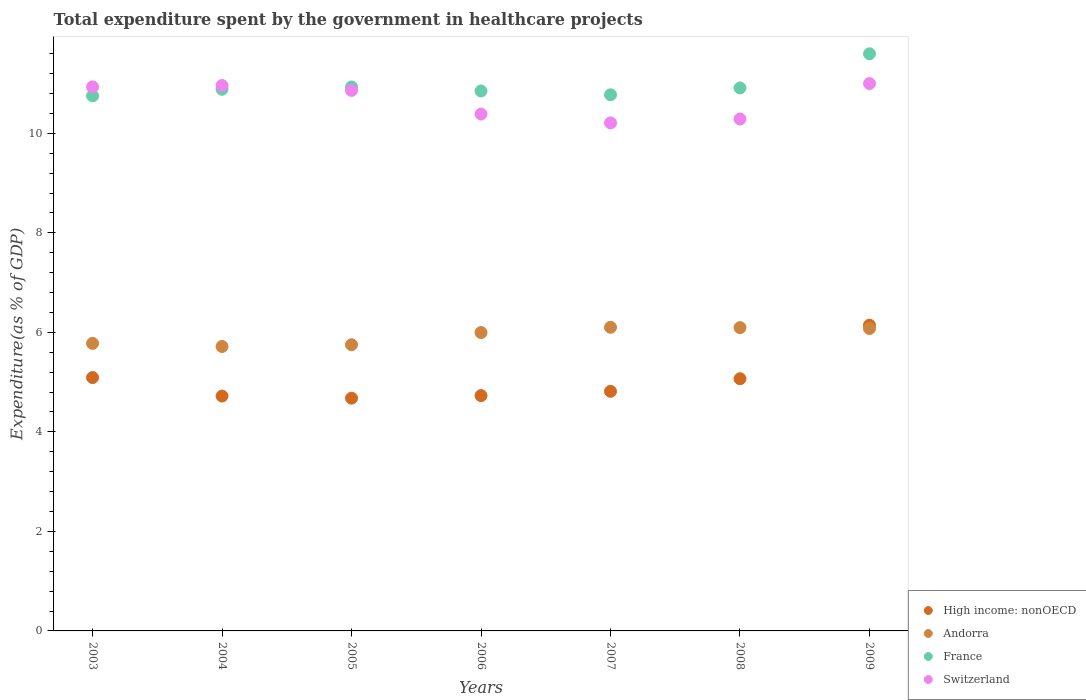What is the total expenditure spent by the government in healthcare projects in High income: nonOECD in 2006?
Your answer should be very brief. 4.73. Across all years, what is the maximum total expenditure spent by the government in healthcare projects in Switzerland?
Make the answer very short. 11. Across all years, what is the minimum total expenditure spent by the government in healthcare projects in Andorra?
Ensure brevity in your answer.  5.72. In which year was the total expenditure spent by the government in healthcare projects in Andorra maximum?
Offer a terse response. 2007. In which year was the total expenditure spent by the government in healthcare projects in France minimum?
Your answer should be compact. 2003. What is the total total expenditure spent by the government in healthcare projects in Switzerland in the graph?
Provide a short and direct response. 74.65. What is the difference between the total expenditure spent by the government in healthcare projects in High income: nonOECD in 2006 and that in 2009?
Your answer should be very brief. -1.42. What is the difference between the total expenditure spent by the government in healthcare projects in Andorra in 2006 and the total expenditure spent by the government in healthcare projects in France in 2007?
Give a very brief answer. -4.78. What is the average total expenditure spent by the government in healthcare projects in France per year?
Give a very brief answer. 10.96. In the year 2008, what is the difference between the total expenditure spent by the government in healthcare projects in High income: nonOECD and total expenditure spent by the government in healthcare projects in Switzerland?
Your response must be concise. -5.22. What is the ratio of the total expenditure spent by the government in healthcare projects in Switzerland in 2007 to that in 2008?
Your response must be concise. 0.99. Is the total expenditure spent by the government in healthcare projects in High income: nonOECD in 2005 less than that in 2006?
Your answer should be very brief. Yes. What is the difference between the highest and the second highest total expenditure spent by the government in healthcare projects in Switzerland?
Your response must be concise. 0.04. What is the difference between the highest and the lowest total expenditure spent by the government in healthcare projects in High income: nonOECD?
Your answer should be very brief. 1.47. Is the sum of the total expenditure spent by the government in healthcare projects in France in 2004 and 2008 greater than the maximum total expenditure spent by the government in healthcare projects in High income: nonOECD across all years?
Offer a very short reply. Yes. Is it the case that in every year, the sum of the total expenditure spent by the government in healthcare projects in High income: nonOECD and total expenditure spent by the government in healthcare projects in Andorra  is greater than the total expenditure spent by the government in healthcare projects in France?
Offer a terse response. No. Does the total expenditure spent by the government in healthcare projects in France monotonically increase over the years?
Your answer should be compact. No. Is the total expenditure spent by the government in healthcare projects in High income: nonOECD strictly less than the total expenditure spent by the government in healthcare projects in Andorra over the years?
Your answer should be very brief. No. How many dotlines are there?
Your response must be concise. 4. How many years are there in the graph?
Offer a terse response. 7. Are the values on the major ticks of Y-axis written in scientific E-notation?
Ensure brevity in your answer.  No. Does the graph contain grids?
Your answer should be compact. No. How many legend labels are there?
Your response must be concise. 4. How are the legend labels stacked?
Give a very brief answer. Vertical. What is the title of the graph?
Give a very brief answer. Total expenditure spent by the government in healthcare projects. What is the label or title of the Y-axis?
Provide a short and direct response. Expenditure(as % of GDP). What is the Expenditure(as % of GDP) of High income: nonOECD in 2003?
Keep it short and to the point. 5.09. What is the Expenditure(as % of GDP) in Andorra in 2003?
Provide a succinct answer. 5.78. What is the Expenditure(as % of GDP) in France in 2003?
Give a very brief answer. 10.75. What is the Expenditure(as % of GDP) of Switzerland in 2003?
Keep it short and to the point. 10.93. What is the Expenditure(as % of GDP) in High income: nonOECD in 2004?
Your response must be concise. 4.72. What is the Expenditure(as % of GDP) of Andorra in 2004?
Your response must be concise. 5.72. What is the Expenditure(as % of GDP) of France in 2004?
Offer a terse response. 10.89. What is the Expenditure(as % of GDP) of Switzerland in 2004?
Ensure brevity in your answer.  10.96. What is the Expenditure(as % of GDP) of High income: nonOECD in 2005?
Offer a very short reply. 4.68. What is the Expenditure(as % of GDP) of Andorra in 2005?
Your answer should be compact. 5.75. What is the Expenditure(as % of GDP) of France in 2005?
Offer a very short reply. 10.93. What is the Expenditure(as % of GDP) in Switzerland in 2005?
Your answer should be very brief. 10.86. What is the Expenditure(as % of GDP) in High income: nonOECD in 2006?
Make the answer very short. 4.73. What is the Expenditure(as % of GDP) of Andorra in 2006?
Provide a short and direct response. 6. What is the Expenditure(as % of GDP) of France in 2006?
Keep it short and to the point. 10.85. What is the Expenditure(as % of GDP) of Switzerland in 2006?
Provide a short and direct response. 10.39. What is the Expenditure(as % of GDP) in High income: nonOECD in 2007?
Provide a succinct answer. 4.82. What is the Expenditure(as % of GDP) of Andorra in 2007?
Give a very brief answer. 6.1. What is the Expenditure(as % of GDP) of France in 2007?
Provide a short and direct response. 10.78. What is the Expenditure(as % of GDP) of Switzerland in 2007?
Make the answer very short. 10.21. What is the Expenditure(as % of GDP) of High income: nonOECD in 2008?
Give a very brief answer. 5.07. What is the Expenditure(as % of GDP) of Andorra in 2008?
Provide a succinct answer. 6.1. What is the Expenditure(as % of GDP) in France in 2008?
Your answer should be very brief. 10.91. What is the Expenditure(as % of GDP) in Switzerland in 2008?
Offer a very short reply. 10.29. What is the Expenditure(as % of GDP) of High income: nonOECD in 2009?
Offer a very short reply. 6.15. What is the Expenditure(as % of GDP) in Andorra in 2009?
Your answer should be compact. 6.08. What is the Expenditure(as % of GDP) of France in 2009?
Offer a terse response. 11.6. What is the Expenditure(as % of GDP) of Switzerland in 2009?
Keep it short and to the point. 11. Across all years, what is the maximum Expenditure(as % of GDP) in High income: nonOECD?
Provide a short and direct response. 6.15. Across all years, what is the maximum Expenditure(as % of GDP) of Andorra?
Offer a terse response. 6.1. Across all years, what is the maximum Expenditure(as % of GDP) of France?
Provide a succinct answer. 11.6. Across all years, what is the maximum Expenditure(as % of GDP) in Switzerland?
Offer a very short reply. 11. Across all years, what is the minimum Expenditure(as % of GDP) in High income: nonOECD?
Your answer should be very brief. 4.68. Across all years, what is the minimum Expenditure(as % of GDP) of Andorra?
Ensure brevity in your answer.  5.72. Across all years, what is the minimum Expenditure(as % of GDP) in France?
Your response must be concise. 10.75. Across all years, what is the minimum Expenditure(as % of GDP) of Switzerland?
Make the answer very short. 10.21. What is the total Expenditure(as % of GDP) in High income: nonOECD in the graph?
Your answer should be compact. 35.25. What is the total Expenditure(as % of GDP) in Andorra in the graph?
Provide a succinct answer. 41.52. What is the total Expenditure(as % of GDP) in France in the graph?
Make the answer very short. 76.71. What is the total Expenditure(as % of GDP) in Switzerland in the graph?
Provide a succinct answer. 74.65. What is the difference between the Expenditure(as % of GDP) of High income: nonOECD in 2003 and that in 2004?
Ensure brevity in your answer.  0.37. What is the difference between the Expenditure(as % of GDP) in Andorra in 2003 and that in 2004?
Your response must be concise. 0.06. What is the difference between the Expenditure(as % of GDP) of France in 2003 and that in 2004?
Make the answer very short. -0.13. What is the difference between the Expenditure(as % of GDP) of Switzerland in 2003 and that in 2004?
Your answer should be very brief. -0.03. What is the difference between the Expenditure(as % of GDP) in High income: nonOECD in 2003 and that in 2005?
Offer a very short reply. 0.41. What is the difference between the Expenditure(as % of GDP) of Andorra in 2003 and that in 2005?
Make the answer very short. 0.03. What is the difference between the Expenditure(as % of GDP) in France in 2003 and that in 2005?
Provide a short and direct response. -0.18. What is the difference between the Expenditure(as % of GDP) in Switzerland in 2003 and that in 2005?
Provide a short and direct response. 0.07. What is the difference between the Expenditure(as % of GDP) in High income: nonOECD in 2003 and that in 2006?
Provide a short and direct response. 0.36. What is the difference between the Expenditure(as % of GDP) of Andorra in 2003 and that in 2006?
Offer a terse response. -0.22. What is the difference between the Expenditure(as % of GDP) in France in 2003 and that in 2006?
Your answer should be very brief. -0.1. What is the difference between the Expenditure(as % of GDP) of Switzerland in 2003 and that in 2006?
Offer a terse response. 0.55. What is the difference between the Expenditure(as % of GDP) of High income: nonOECD in 2003 and that in 2007?
Your response must be concise. 0.28. What is the difference between the Expenditure(as % of GDP) of Andorra in 2003 and that in 2007?
Your answer should be very brief. -0.32. What is the difference between the Expenditure(as % of GDP) of France in 2003 and that in 2007?
Keep it short and to the point. -0.02. What is the difference between the Expenditure(as % of GDP) in Switzerland in 2003 and that in 2007?
Provide a short and direct response. 0.72. What is the difference between the Expenditure(as % of GDP) in High income: nonOECD in 2003 and that in 2008?
Keep it short and to the point. 0.02. What is the difference between the Expenditure(as % of GDP) in Andorra in 2003 and that in 2008?
Offer a terse response. -0.32. What is the difference between the Expenditure(as % of GDP) in France in 2003 and that in 2008?
Provide a succinct answer. -0.16. What is the difference between the Expenditure(as % of GDP) of Switzerland in 2003 and that in 2008?
Offer a very short reply. 0.65. What is the difference between the Expenditure(as % of GDP) in High income: nonOECD in 2003 and that in 2009?
Your answer should be compact. -1.05. What is the difference between the Expenditure(as % of GDP) in Andorra in 2003 and that in 2009?
Ensure brevity in your answer.  -0.3. What is the difference between the Expenditure(as % of GDP) in France in 2003 and that in 2009?
Your answer should be compact. -0.85. What is the difference between the Expenditure(as % of GDP) in Switzerland in 2003 and that in 2009?
Provide a short and direct response. -0.07. What is the difference between the Expenditure(as % of GDP) in High income: nonOECD in 2004 and that in 2005?
Offer a terse response. 0.04. What is the difference between the Expenditure(as % of GDP) in Andorra in 2004 and that in 2005?
Make the answer very short. -0.03. What is the difference between the Expenditure(as % of GDP) in France in 2004 and that in 2005?
Your answer should be very brief. -0.05. What is the difference between the Expenditure(as % of GDP) in Switzerland in 2004 and that in 2005?
Your response must be concise. 0.1. What is the difference between the Expenditure(as % of GDP) of High income: nonOECD in 2004 and that in 2006?
Keep it short and to the point. -0.01. What is the difference between the Expenditure(as % of GDP) of Andorra in 2004 and that in 2006?
Your answer should be compact. -0.28. What is the difference between the Expenditure(as % of GDP) in France in 2004 and that in 2006?
Provide a short and direct response. 0.03. What is the difference between the Expenditure(as % of GDP) of Switzerland in 2004 and that in 2006?
Make the answer very short. 0.57. What is the difference between the Expenditure(as % of GDP) in High income: nonOECD in 2004 and that in 2007?
Give a very brief answer. -0.1. What is the difference between the Expenditure(as % of GDP) in Andorra in 2004 and that in 2007?
Keep it short and to the point. -0.39. What is the difference between the Expenditure(as % of GDP) in France in 2004 and that in 2007?
Give a very brief answer. 0.11. What is the difference between the Expenditure(as % of GDP) in Switzerland in 2004 and that in 2007?
Ensure brevity in your answer.  0.75. What is the difference between the Expenditure(as % of GDP) of High income: nonOECD in 2004 and that in 2008?
Your response must be concise. -0.35. What is the difference between the Expenditure(as % of GDP) in Andorra in 2004 and that in 2008?
Provide a succinct answer. -0.38. What is the difference between the Expenditure(as % of GDP) in France in 2004 and that in 2008?
Ensure brevity in your answer.  -0.03. What is the difference between the Expenditure(as % of GDP) of Switzerland in 2004 and that in 2008?
Keep it short and to the point. 0.67. What is the difference between the Expenditure(as % of GDP) of High income: nonOECD in 2004 and that in 2009?
Your response must be concise. -1.42. What is the difference between the Expenditure(as % of GDP) of Andorra in 2004 and that in 2009?
Provide a succinct answer. -0.36. What is the difference between the Expenditure(as % of GDP) in France in 2004 and that in 2009?
Give a very brief answer. -0.71. What is the difference between the Expenditure(as % of GDP) of Switzerland in 2004 and that in 2009?
Provide a succinct answer. -0.04. What is the difference between the Expenditure(as % of GDP) of High income: nonOECD in 2005 and that in 2006?
Give a very brief answer. -0.05. What is the difference between the Expenditure(as % of GDP) of Andorra in 2005 and that in 2006?
Offer a very short reply. -0.25. What is the difference between the Expenditure(as % of GDP) in France in 2005 and that in 2006?
Offer a very short reply. 0.08. What is the difference between the Expenditure(as % of GDP) in Switzerland in 2005 and that in 2006?
Provide a short and direct response. 0.48. What is the difference between the Expenditure(as % of GDP) of High income: nonOECD in 2005 and that in 2007?
Your answer should be very brief. -0.14. What is the difference between the Expenditure(as % of GDP) in Andorra in 2005 and that in 2007?
Ensure brevity in your answer.  -0.35. What is the difference between the Expenditure(as % of GDP) of France in 2005 and that in 2007?
Offer a very short reply. 0.16. What is the difference between the Expenditure(as % of GDP) in Switzerland in 2005 and that in 2007?
Make the answer very short. 0.65. What is the difference between the Expenditure(as % of GDP) in High income: nonOECD in 2005 and that in 2008?
Offer a terse response. -0.39. What is the difference between the Expenditure(as % of GDP) of Andorra in 2005 and that in 2008?
Make the answer very short. -0.34. What is the difference between the Expenditure(as % of GDP) of France in 2005 and that in 2008?
Ensure brevity in your answer.  0.02. What is the difference between the Expenditure(as % of GDP) of Switzerland in 2005 and that in 2008?
Provide a succinct answer. 0.57. What is the difference between the Expenditure(as % of GDP) of High income: nonOECD in 2005 and that in 2009?
Ensure brevity in your answer.  -1.47. What is the difference between the Expenditure(as % of GDP) of Andorra in 2005 and that in 2009?
Your answer should be very brief. -0.33. What is the difference between the Expenditure(as % of GDP) of France in 2005 and that in 2009?
Keep it short and to the point. -0.67. What is the difference between the Expenditure(as % of GDP) of Switzerland in 2005 and that in 2009?
Provide a short and direct response. -0.14. What is the difference between the Expenditure(as % of GDP) in High income: nonOECD in 2006 and that in 2007?
Your answer should be very brief. -0.09. What is the difference between the Expenditure(as % of GDP) in Andorra in 2006 and that in 2007?
Give a very brief answer. -0.11. What is the difference between the Expenditure(as % of GDP) of France in 2006 and that in 2007?
Give a very brief answer. 0.08. What is the difference between the Expenditure(as % of GDP) of Switzerland in 2006 and that in 2007?
Your answer should be very brief. 0.18. What is the difference between the Expenditure(as % of GDP) in High income: nonOECD in 2006 and that in 2008?
Ensure brevity in your answer.  -0.34. What is the difference between the Expenditure(as % of GDP) in Andorra in 2006 and that in 2008?
Provide a short and direct response. -0.1. What is the difference between the Expenditure(as % of GDP) in France in 2006 and that in 2008?
Provide a short and direct response. -0.06. What is the difference between the Expenditure(as % of GDP) of Switzerland in 2006 and that in 2008?
Your answer should be very brief. 0.1. What is the difference between the Expenditure(as % of GDP) in High income: nonOECD in 2006 and that in 2009?
Give a very brief answer. -1.42. What is the difference between the Expenditure(as % of GDP) in Andorra in 2006 and that in 2009?
Give a very brief answer. -0.08. What is the difference between the Expenditure(as % of GDP) of France in 2006 and that in 2009?
Your response must be concise. -0.75. What is the difference between the Expenditure(as % of GDP) of Switzerland in 2006 and that in 2009?
Your answer should be compact. -0.61. What is the difference between the Expenditure(as % of GDP) in High income: nonOECD in 2007 and that in 2008?
Ensure brevity in your answer.  -0.25. What is the difference between the Expenditure(as % of GDP) in Andorra in 2007 and that in 2008?
Your response must be concise. 0.01. What is the difference between the Expenditure(as % of GDP) in France in 2007 and that in 2008?
Give a very brief answer. -0.14. What is the difference between the Expenditure(as % of GDP) in Switzerland in 2007 and that in 2008?
Your answer should be compact. -0.08. What is the difference between the Expenditure(as % of GDP) of High income: nonOECD in 2007 and that in 2009?
Ensure brevity in your answer.  -1.33. What is the difference between the Expenditure(as % of GDP) in Andorra in 2007 and that in 2009?
Offer a terse response. 0.03. What is the difference between the Expenditure(as % of GDP) of France in 2007 and that in 2009?
Make the answer very short. -0.82. What is the difference between the Expenditure(as % of GDP) in Switzerland in 2007 and that in 2009?
Ensure brevity in your answer.  -0.79. What is the difference between the Expenditure(as % of GDP) in High income: nonOECD in 2008 and that in 2009?
Offer a very short reply. -1.08. What is the difference between the Expenditure(as % of GDP) in Andorra in 2008 and that in 2009?
Your answer should be very brief. 0.02. What is the difference between the Expenditure(as % of GDP) in France in 2008 and that in 2009?
Offer a terse response. -0.69. What is the difference between the Expenditure(as % of GDP) of Switzerland in 2008 and that in 2009?
Provide a short and direct response. -0.71. What is the difference between the Expenditure(as % of GDP) in High income: nonOECD in 2003 and the Expenditure(as % of GDP) in Andorra in 2004?
Keep it short and to the point. -0.62. What is the difference between the Expenditure(as % of GDP) of High income: nonOECD in 2003 and the Expenditure(as % of GDP) of France in 2004?
Give a very brief answer. -5.79. What is the difference between the Expenditure(as % of GDP) in High income: nonOECD in 2003 and the Expenditure(as % of GDP) in Switzerland in 2004?
Your response must be concise. -5.87. What is the difference between the Expenditure(as % of GDP) in Andorra in 2003 and the Expenditure(as % of GDP) in France in 2004?
Make the answer very short. -5.11. What is the difference between the Expenditure(as % of GDP) of Andorra in 2003 and the Expenditure(as % of GDP) of Switzerland in 2004?
Provide a short and direct response. -5.18. What is the difference between the Expenditure(as % of GDP) of France in 2003 and the Expenditure(as % of GDP) of Switzerland in 2004?
Keep it short and to the point. -0.21. What is the difference between the Expenditure(as % of GDP) of High income: nonOECD in 2003 and the Expenditure(as % of GDP) of Andorra in 2005?
Your answer should be compact. -0.66. What is the difference between the Expenditure(as % of GDP) of High income: nonOECD in 2003 and the Expenditure(as % of GDP) of France in 2005?
Your response must be concise. -5.84. What is the difference between the Expenditure(as % of GDP) in High income: nonOECD in 2003 and the Expenditure(as % of GDP) in Switzerland in 2005?
Provide a succinct answer. -5.77. What is the difference between the Expenditure(as % of GDP) in Andorra in 2003 and the Expenditure(as % of GDP) in France in 2005?
Your response must be concise. -5.15. What is the difference between the Expenditure(as % of GDP) of Andorra in 2003 and the Expenditure(as % of GDP) of Switzerland in 2005?
Ensure brevity in your answer.  -5.08. What is the difference between the Expenditure(as % of GDP) in France in 2003 and the Expenditure(as % of GDP) in Switzerland in 2005?
Your response must be concise. -0.11. What is the difference between the Expenditure(as % of GDP) of High income: nonOECD in 2003 and the Expenditure(as % of GDP) of Andorra in 2006?
Offer a terse response. -0.91. What is the difference between the Expenditure(as % of GDP) of High income: nonOECD in 2003 and the Expenditure(as % of GDP) of France in 2006?
Keep it short and to the point. -5.76. What is the difference between the Expenditure(as % of GDP) in High income: nonOECD in 2003 and the Expenditure(as % of GDP) in Switzerland in 2006?
Ensure brevity in your answer.  -5.3. What is the difference between the Expenditure(as % of GDP) of Andorra in 2003 and the Expenditure(as % of GDP) of France in 2006?
Ensure brevity in your answer.  -5.07. What is the difference between the Expenditure(as % of GDP) in Andorra in 2003 and the Expenditure(as % of GDP) in Switzerland in 2006?
Offer a very short reply. -4.61. What is the difference between the Expenditure(as % of GDP) in France in 2003 and the Expenditure(as % of GDP) in Switzerland in 2006?
Your response must be concise. 0.37. What is the difference between the Expenditure(as % of GDP) in High income: nonOECD in 2003 and the Expenditure(as % of GDP) in Andorra in 2007?
Offer a very short reply. -1.01. What is the difference between the Expenditure(as % of GDP) in High income: nonOECD in 2003 and the Expenditure(as % of GDP) in France in 2007?
Your answer should be compact. -5.68. What is the difference between the Expenditure(as % of GDP) of High income: nonOECD in 2003 and the Expenditure(as % of GDP) of Switzerland in 2007?
Provide a succinct answer. -5.12. What is the difference between the Expenditure(as % of GDP) in Andorra in 2003 and the Expenditure(as % of GDP) in France in 2007?
Make the answer very short. -5. What is the difference between the Expenditure(as % of GDP) of Andorra in 2003 and the Expenditure(as % of GDP) of Switzerland in 2007?
Keep it short and to the point. -4.43. What is the difference between the Expenditure(as % of GDP) in France in 2003 and the Expenditure(as % of GDP) in Switzerland in 2007?
Your response must be concise. 0.54. What is the difference between the Expenditure(as % of GDP) in High income: nonOECD in 2003 and the Expenditure(as % of GDP) in Andorra in 2008?
Provide a succinct answer. -1. What is the difference between the Expenditure(as % of GDP) of High income: nonOECD in 2003 and the Expenditure(as % of GDP) of France in 2008?
Make the answer very short. -5.82. What is the difference between the Expenditure(as % of GDP) in High income: nonOECD in 2003 and the Expenditure(as % of GDP) in Switzerland in 2008?
Your answer should be compact. -5.2. What is the difference between the Expenditure(as % of GDP) in Andorra in 2003 and the Expenditure(as % of GDP) in France in 2008?
Your response must be concise. -5.13. What is the difference between the Expenditure(as % of GDP) in Andorra in 2003 and the Expenditure(as % of GDP) in Switzerland in 2008?
Your answer should be very brief. -4.51. What is the difference between the Expenditure(as % of GDP) in France in 2003 and the Expenditure(as % of GDP) in Switzerland in 2008?
Your response must be concise. 0.46. What is the difference between the Expenditure(as % of GDP) of High income: nonOECD in 2003 and the Expenditure(as % of GDP) of Andorra in 2009?
Your response must be concise. -0.99. What is the difference between the Expenditure(as % of GDP) of High income: nonOECD in 2003 and the Expenditure(as % of GDP) of France in 2009?
Keep it short and to the point. -6.51. What is the difference between the Expenditure(as % of GDP) of High income: nonOECD in 2003 and the Expenditure(as % of GDP) of Switzerland in 2009?
Ensure brevity in your answer.  -5.91. What is the difference between the Expenditure(as % of GDP) in Andorra in 2003 and the Expenditure(as % of GDP) in France in 2009?
Your answer should be very brief. -5.82. What is the difference between the Expenditure(as % of GDP) of Andorra in 2003 and the Expenditure(as % of GDP) of Switzerland in 2009?
Give a very brief answer. -5.22. What is the difference between the Expenditure(as % of GDP) of France in 2003 and the Expenditure(as % of GDP) of Switzerland in 2009?
Your response must be concise. -0.25. What is the difference between the Expenditure(as % of GDP) in High income: nonOECD in 2004 and the Expenditure(as % of GDP) in Andorra in 2005?
Keep it short and to the point. -1.03. What is the difference between the Expenditure(as % of GDP) in High income: nonOECD in 2004 and the Expenditure(as % of GDP) in France in 2005?
Your answer should be compact. -6.21. What is the difference between the Expenditure(as % of GDP) in High income: nonOECD in 2004 and the Expenditure(as % of GDP) in Switzerland in 2005?
Your answer should be very brief. -6.14. What is the difference between the Expenditure(as % of GDP) in Andorra in 2004 and the Expenditure(as % of GDP) in France in 2005?
Your response must be concise. -5.22. What is the difference between the Expenditure(as % of GDP) in Andorra in 2004 and the Expenditure(as % of GDP) in Switzerland in 2005?
Offer a very short reply. -5.15. What is the difference between the Expenditure(as % of GDP) in France in 2004 and the Expenditure(as % of GDP) in Switzerland in 2005?
Ensure brevity in your answer.  0.02. What is the difference between the Expenditure(as % of GDP) in High income: nonOECD in 2004 and the Expenditure(as % of GDP) in Andorra in 2006?
Provide a succinct answer. -1.28. What is the difference between the Expenditure(as % of GDP) of High income: nonOECD in 2004 and the Expenditure(as % of GDP) of France in 2006?
Offer a terse response. -6.13. What is the difference between the Expenditure(as % of GDP) in High income: nonOECD in 2004 and the Expenditure(as % of GDP) in Switzerland in 2006?
Provide a succinct answer. -5.67. What is the difference between the Expenditure(as % of GDP) in Andorra in 2004 and the Expenditure(as % of GDP) in France in 2006?
Ensure brevity in your answer.  -5.14. What is the difference between the Expenditure(as % of GDP) in Andorra in 2004 and the Expenditure(as % of GDP) in Switzerland in 2006?
Offer a terse response. -4.67. What is the difference between the Expenditure(as % of GDP) in France in 2004 and the Expenditure(as % of GDP) in Switzerland in 2006?
Your answer should be compact. 0.5. What is the difference between the Expenditure(as % of GDP) in High income: nonOECD in 2004 and the Expenditure(as % of GDP) in Andorra in 2007?
Make the answer very short. -1.38. What is the difference between the Expenditure(as % of GDP) of High income: nonOECD in 2004 and the Expenditure(as % of GDP) of France in 2007?
Provide a short and direct response. -6.05. What is the difference between the Expenditure(as % of GDP) in High income: nonOECD in 2004 and the Expenditure(as % of GDP) in Switzerland in 2007?
Give a very brief answer. -5.49. What is the difference between the Expenditure(as % of GDP) in Andorra in 2004 and the Expenditure(as % of GDP) in France in 2007?
Give a very brief answer. -5.06. What is the difference between the Expenditure(as % of GDP) in Andorra in 2004 and the Expenditure(as % of GDP) in Switzerland in 2007?
Offer a very short reply. -4.49. What is the difference between the Expenditure(as % of GDP) in France in 2004 and the Expenditure(as % of GDP) in Switzerland in 2007?
Provide a short and direct response. 0.68. What is the difference between the Expenditure(as % of GDP) of High income: nonOECD in 2004 and the Expenditure(as % of GDP) of Andorra in 2008?
Provide a succinct answer. -1.38. What is the difference between the Expenditure(as % of GDP) of High income: nonOECD in 2004 and the Expenditure(as % of GDP) of France in 2008?
Offer a terse response. -6.19. What is the difference between the Expenditure(as % of GDP) in High income: nonOECD in 2004 and the Expenditure(as % of GDP) in Switzerland in 2008?
Offer a terse response. -5.57. What is the difference between the Expenditure(as % of GDP) of Andorra in 2004 and the Expenditure(as % of GDP) of France in 2008?
Your answer should be compact. -5.2. What is the difference between the Expenditure(as % of GDP) in Andorra in 2004 and the Expenditure(as % of GDP) in Switzerland in 2008?
Your answer should be compact. -4.57. What is the difference between the Expenditure(as % of GDP) of France in 2004 and the Expenditure(as % of GDP) of Switzerland in 2008?
Keep it short and to the point. 0.6. What is the difference between the Expenditure(as % of GDP) of High income: nonOECD in 2004 and the Expenditure(as % of GDP) of Andorra in 2009?
Make the answer very short. -1.36. What is the difference between the Expenditure(as % of GDP) in High income: nonOECD in 2004 and the Expenditure(as % of GDP) in France in 2009?
Give a very brief answer. -6.88. What is the difference between the Expenditure(as % of GDP) in High income: nonOECD in 2004 and the Expenditure(as % of GDP) in Switzerland in 2009?
Your response must be concise. -6.28. What is the difference between the Expenditure(as % of GDP) in Andorra in 2004 and the Expenditure(as % of GDP) in France in 2009?
Provide a succinct answer. -5.88. What is the difference between the Expenditure(as % of GDP) of Andorra in 2004 and the Expenditure(as % of GDP) of Switzerland in 2009?
Offer a very short reply. -5.28. What is the difference between the Expenditure(as % of GDP) in France in 2004 and the Expenditure(as % of GDP) in Switzerland in 2009?
Give a very brief answer. -0.11. What is the difference between the Expenditure(as % of GDP) of High income: nonOECD in 2005 and the Expenditure(as % of GDP) of Andorra in 2006?
Offer a very short reply. -1.32. What is the difference between the Expenditure(as % of GDP) in High income: nonOECD in 2005 and the Expenditure(as % of GDP) in France in 2006?
Your answer should be very brief. -6.17. What is the difference between the Expenditure(as % of GDP) in High income: nonOECD in 2005 and the Expenditure(as % of GDP) in Switzerland in 2006?
Give a very brief answer. -5.71. What is the difference between the Expenditure(as % of GDP) in Andorra in 2005 and the Expenditure(as % of GDP) in France in 2006?
Your answer should be very brief. -5.1. What is the difference between the Expenditure(as % of GDP) of Andorra in 2005 and the Expenditure(as % of GDP) of Switzerland in 2006?
Offer a terse response. -4.64. What is the difference between the Expenditure(as % of GDP) of France in 2005 and the Expenditure(as % of GDP) of Switzerland in 2006?
Your answer should be very brief. 0.54. What is the difference between the Expenditure(as % of GDP) of High income: nonOECD in 2005 and the Expenditure(as % of GDP) of Andorra in 2007?
Provide a short and direct response. -1.43. What is the difference between the Expenditure(as % of GDP) of High income: nonOECD in 2005 and the Expenditure(as % of GDP) of France in 2007?
Provide a succinct answer. -6.1. What is the difference between the Expenditure(as % of GDP) in High income: nonOECD in 2005 and the Expenditure(as % of GDP) in Switzerland in 2007?
Your response must be concise. -5.53. What is the difference between the Expenditure(as % of GDP) of Andorra in 2005 and the Expenditure(as % of GDP) of France in 2007?
Your response must be concise. -5.02. What is the difference between the Expenditure(as % of GDP) in Andorra in 2005 and the Expenditure(as % of GDP) in Switzerland in 2007?
Ensure brevity in your answer.  -4.46. What is the difference between the Expenditure(as % of GDP) in France in 2005 and the Expenditure(as % of GDP) in Switzerland in 2007?
Your response must be concise. 0.72. What is the difference between the Expenditure(as % of GDP) of High income: nonOECD in 2005 and the Expenditure(as % of GDP) of Andorra in 2008?
Provide a short and direct response. -1.42. What is the difference between the Expenditure(as % of GDP) of High income: nonOECD in 2005 and the Expenditure(as % of GDP) of France in 2008?
Your answer should be compact. -6.24. What is the difference between the Expenditure(as % of GDP) of High income: nonOECD in 2005 and the Expenditure(as % of GDP) of Switzerland in 2008?
Your answer should be very brief. -5.61. What is the difference between the Expenditure(as % of GDP) of Andorra in 2005 and the Expenditure(as % of GDP) of France in 2008?
Make the answer very short. -5.16. What is the difference between the Expenditure(as % of GDP) in Andorra in 2005 and the Expenditure(as % of GDP) in Switzerland in 2008?
Your answer should be very brief. -4.54. What is the difference between the Expenditure(as % of GDP) of France in 2005 and the Expenditure(as % of GDP) of Switzerland in 2008?
Your response must be concise. 0.64. What is the difference between the Expenditure(as % of GDP) of High income: nonOECD in 2005 and the Expenditure(as % of GDP) of Andorra in 2009?
Offer a terse response. -1.4. What is the difference between the Expenditure(as % of GDP) in High income: nonOECD in 2005 and the Expenditure(as % of GDP) in France in 2009?
Ensure brevity in your answer.  -6.92. What is the difference between the Expenditure(as % of GDP) of High income: nonOECD in 2005 and the Expenditure(as % of GDP) of Switzerland in 2009?
Give a very brief answer. -6.32. What is the difference between the Expenditure(as % of GDP) of Andorra in 2005 and the Expenditure(as % of GDP) of France in 2009?
Your answer should be very brief. -5.85. What is the difference between the Expenditure(as % of GDP) in Andorra in 2005 and the Expenditure(as % of GDP) in Switzerland in 2009?
Offer a terse response. -5.25. What is the difference between the Expenditure(as % of GDP) of France in 2005 and the Expenditure(as % of GDP) of Switzerland in 2009?
Offer a very short reply. -0.07. What is the difference between the Expenditure(as % of GDP) in High income: nonOECD in 2006 and the Expenditure(as % of GDP) in Andorra in 2007?
Provide a succinct answer. -1.37. What is the difference between the Expenditure(as % of GDP) in High income: nonOECD in 2006 and the Expenditure(as % of GDP) in France in 2007?
Keep it short and to the point. -6.05. What is the difference between the Expenditure(as % of GDP) of High income: nonOECD in 2006 and the Expenditure(as % of GDP) of Switzerland in 2007?
Provide a short and direct response. -5.48. What is the difference between the Expenditure(as % of GDP) of Andorra in 2006 and the Expenditure(as % of GDP) of France in 2007?
Offer a terse response. -4.78. What is the difference between the Expenditure(as % of GDP) of Andorra in 2006 and the Expenditure(as % of GDP) of Switzerland in 2007?
Provide a succinct answer. -4.21. What is the difference between the Expenditure(as % of GDP) of France in 2006 and the Expenditure(as % of GDP) of Switzerland in 2007?
Keep it short and to the point. 0.64. What is the difference between the Expenditure(as % of GDP) of High income: nonOECD in 2006 and the Expenditure(as % of GDP) of Andorra in 2008?
Ensure brevity in your answer.  -1.37. What is the difference between the Expenditure(as % of GDP) of High income: nonOECD in 2006 and the Expenditure(as % of GDP) of France in 2008?
Your answer should be very brief. -6.18. What is the difference between the Expenditure(as % of GDP) of High income: nonOECD in 2006 and the Expenditure(as % of GDP) of Switzerland in 2008?
Your response must be concise. -5.56. What is the difference between the Expenditure(as % of GDP) in Andorra in 2006 and the Expenditure(as % of GDP) in France in 2008?
Ensure brevity in your answer.  -4.92. What is the difference between the Expenditure(as % of GDP) in Andorra in 2006 and the Expenditure(as % of GDP) in Switzerland in 2008?
Provide a short and direct response. -4.29. What is the difference between the Expenditure(as % of GDP) of France in 2006 and the Expenditure(as % of GDP) of Switzerland in 2008?
Offer a very short reply. 0.56. What is the difference between the Expenditure(as % of GDP) of High income: nonOECD in 2006 and the Expenditure(as % of GDP) of Andorra in 2009?
Your response must be concise. -1.35. What is the difference between the Expenditure(as % of GDP) of High income: nonOECD in 2006 and the Expenditure(as % of GDP) of France in 2009?
Offer a terse response. -6.87. What is the difference between the Expenditure(as % of GDP) of High income: nonOECD in 2006 and the Expenditure(as % of GDP) of Switzerland in 2009?
Ensure brevity in your answer.  -6.27. What is the difference between the Expenditure(as % of GDP) in Andorra in 2006 and the Expenditure(as % of GDP) in France in 2009?
Provide a succinct answer. -5.6. What is the difference between the Expenditure(as % of GDP) of Andorra in 2006 and the Expenditure(as % of GDP) of Switzerland in 2009?
Give a very brief answer. -5. What is the difference between the Expenditure(as % of GDP) of France in 2006 and the Expenditure(as % of GDP) of Switzerland in 2009?
Offer a terse response. -0.15. What is the difference between the Expenditure(as % of GDP) of High income: nonOECD in 2007 and the Expenditure(as % of GDP) of Andorra in 2008?
Your answer should be very brief. -1.28. What is the difference between the Expenditure(as % of GDP) in High income: nonOECD in 2007 and the Expenditure(as % of GDP) in France in 2008?
Offer a very short reply. -6.1. What is the difference between the Expenditure(as % of GDP) in High income: nonOECD in 2007 and the Expenditure(as % of GDP) in Switzerland in 2008?
Offer a terse response. -5.47. What is the difference between the Expenditure(as % of GDP) in Andorra in 2007 and the Expenditure(as % of GDP) in France in 2008?
Ensure brevity in your answer.  -4.81. What is the difference between the Expenditure(as % of GDP) of Andorra in 2007 and the Expenditure(as % of GDP) of Switzerland in 2008?
Give a very brief answer. -4.19. What is the difference between the Expenditure(as % of GDP) in France in 2007 and the Expenditure(as % of GDP) in Switzerland in 2008?
Offer a terse response. 0.49. What is the difference between the Expenditure(as % of GDP) in High income: nonOECD in 2007 and the Expenditure(as % of GDP) in Andorra in 2009?
Offer a very short reply. -1.26. What is the difference between the Expenditure(as % of GDP) of High income: nonOECD in 2007 and the Expenditure(as % of GDP) of France in 2009?
Your answer should be very brief. -6.78. What is the difference between the Expenditure(as % of GDP) in High income: nonOECD in 2007 and the Expenditure(as % of GDP) in Switzerland in 2009?
Give a very brief answer. -6.18. What is the difference between the Expenditure(as % of GDP) in Andorra in 2007 and the Expenditure(as % of GDP) in France in 2009?
Your answer should be very brief. -5.5. What is the difference between the Expenditure(as % of GDP) in Andorra in 2007 and the Expenditure(as % of GDP) in Switzerland in 2009?
Your answer should be compact. -4.9. What is the difference between the Expenditure(as % of GDP) of France in 2007 and the Expenditure(as % of GDP) of Switzerland in 2009?
Provide a short and direct response. -0.23. What is the difference between the Expenditure(as % of GDP) in High income: nonOECD in 2008 and the Expenditure(as % of GDP) in Andorra in 2009?
Make the answer very short. -1.01. What is the difference between the Expenditure(as % of GDP) in High income: nonOECD in 2008 and the Expenditure(as % of GDP) in France in 2009?
Give a very brief answer. -6.53. What is the difference between the Expenditure(as % of GDP) of High income: nonOECD in 2008 and the Expenditure(as % of GDP) of Switzerland in 2009?
Provide a succinct answer. -5.93. What is the difference between the Expenditure(as % of GDP) in Andorra in 2008 and the Expenditure(as % of GDP) in France in 2009?
Provide a short and direct response. -5.5. What is the difference between the Expenditure(as % of GDP) of Andorra in 2008 and the Expenditure(as % of GDP) of Switzerland in 2009?
Make the answer very short. -4.9. What is the difference between the Expenditure(as % of GDP) in France in 2008 and the Expenditure(as % of GDP) in Switzerland in 2009?
Offer a very short reply. -0.09. What is the average Expenditure(as % of GDP) in High income: nonOECD per year?
Ensure brevity in your answer.  5.04. What is the average Expenditure(as % of GDP) in Andorra per year?
Offer a very short reply. 5.93. What is the average Expenditure(as % of GDP) of France per year?
Offer a terse response. 10.96. What is the average Expenditure(as % of GDP) of Switzerland per year?
Your response must be concise. 10.66. In the year 2003, what is the difference between the Expenditure(as % of GDP) in High income: nonOECD and Expenditure(as % of GDP) in Andorra?
Give a very brief answer. -0.69. In the year 2003, what is the difference between the Expenditure(as % of GDP) in High income: nonOECD and Expenditure(as % of GDP) in France?
Your answer should be very brief. -5.66. In the year 2003, what is the difference between the Expenditure(as % of GDP) of High income: nonOECD and Expenditure(as % of GDP) of Switzerland?
Provide a succinct answer. -5.84. In the year 2003, what is the difference between the Expenditure(as % of GDP) of Andorra and Expenditure(as % of GDP) of France?
Your response must be concise. -4.97. In the year 2003, what is the difference between the Expenditure(as % of GDP) of Andorra and Expenditure(as % of GDP) of Switzerland?
Your answer should be compact. -5.15. In the year 2003, what is the difference between the Expenditure(as % of GDP) of France and Expenditure(as % of GDP) of Switzerland?
Ensure brevity in your answer.  -0.18. In the year 2004, what is the difference between the Expenditure(as % of GDP) in High income: nonOECD and Expenditure(as % of GDP) in Andorra?
Your response must be concise. -1. In the year 2004, what is the difference between the Expenditure(as % of GDP) of High income: nonOECD and Expenditure(as % of GDP) of France?
Provide a succinct answer. -6.17. In the year 2004, what is the difference between the Expenditure(as % of GDP) of High income: nonOECD and Expenditure(as % of GDP) of Switzerland?
Ensure brevity in your answer.  -6.24. In the year 2004, what is the difference between the Expenditure(as % of GDP) of Andorra and Expenditure(as % of GDP) of France?
Provide a short and direct response. -5.17. In the year 2004, what is the difference between the Expenditure(as % of GDP) in Andorra and Expenditure(as % of GDP) in Switzerland?
Your answer should be compact. -5.24. In the year 2004, what is the difference between the Expenditure(as % of GDP) in France and Expenditure(as % of GDP) in Switzerland?
Offer a terse response. -0.08. In the year 2005, what is the difference between the Expenditure(as % of GDP) of High income: nonOECD and Expenditure(as % of GDP) of Andorra?
Provide a short and direct response. -1.07. In the year 2005, what is the difference between the Expenditure(as % of GDP) in High income: nonOECD and Expenditure(as % of GDP) in France?
Make the answer very short. -6.26. In the year 2005, what is the difference between the Expenditure(as % of GDP) in High income: nonOECD and Expenditure(as % of GDP) in Switzerland?
Give a very brief answer. -6.19. In the year 2005, what is the difference between the Expenditure(as % of GDP) of Andorra and Expenditure(as % of GDP) of France?
Offer a very short reply. -5.18. In the year 2005, what is the difference between the Expenditure(as % of GDP) in Andorra and Expenditure(as % of GDP) in Switzerland?
Keep it short and to the point. -5.11. In the year 2005, what is the difference between the Expenditure(as % of GDP) of France and Expenditure(as % of GDP) of Switzerland?
Provide a short and direct response. 0.07. In the year 2006, what is the difference between the Expenditure(as % of GDP) in High income: nonOECD and Expenditure(as % of GDP) in Andorra?
Ensure brevity in your answer.  -1.27. In the year 2006, what is the difference between the Expenditure(as % of GDP) of High income: nonOECD and Expenditure(as % of GDP) of France?
Offer a terse response. -6.12. In the year 2006, what is the difference between the Expenditure(as % of GDP) of High income: nonOECD and Expenditure(as % of GDP) of Switzerland?
Your response must be concise. -5.66. In the year 2006, what is the difference between the Expenditure(as % of GDP) of Andorra and Expenditure(as % of GDP) of France?
Offer a very short reply. -4.86. In the year 2006, what is the difference between the Expenditure(as % of GDP) in Andorra and Expenditure(as % of GDP) in Switzerland?
Provide a succinct answer. -4.39. In the year 2006, what is the difference between the Expenditure(as % of GDP) in France and Expenditure(as % of GDP) in Switzerland?
Provide a succinct answer. 0.46. In the year 2007, what is the difference between the Expenditure(as % of GDP) of High income: nonOECD and Expenditure(as % of GDP) of Andorra?
Make the answer very short. -1.29. In the year 2007, what is the difference between the Expenditure(as % of GDP) in High income: nonOECD and Expenditure(as % of GDP) in France?
Your answer should be very brief. -5.96. In the year 2007, what is the difference between the Expenditure(as % of GDP) of High income: nonOECD and Expenditure(as % of GDP) of Switzerland?
Your answer should be compact. -5.39. In the year 2007, what is the difference between the Expenditure(as % of GDP) in Andorra and Expenditure(as % of GDP) in France?
Keep it short and to the point. -4.67. In the year 2007, what is the difference between the Expenditure(as % of GDP) in Andorra and Expenditure(as % of GDP) in Switzerland?
Give a very brief answer. -4.11. In the year 2007, what is the difference between the Expenditure(as % of GDP) in France and Expenditure(as % of GDP) in Switzerland?
Your answer should be compact. 0.57. In the year 2008, what is the difference between the Expenditure(as % of GDP) of High income: nonOECD and Expenditure(as % of GDP) of Andorra?
Offer a very short reply. -1.03. In the year 2008, what is the difference between the Expenditure(as % of GDP) in High income: nonOECD and Expenditure(as % of GDP) in France?
Offer a very short reply. -5.84. In the year 2008, what is the difference between the Expenditure(as % of GDP) of High income: nonOECD and Expenditure(as % of GDP) of Switzerland?
Your response must be concise. -5.22. In the year 2008, what is the difference between the Expenditure(as % of GDP) of Andorra and Expenditure(as % of GDP) of France?
Ensure brevity in your answer.  -4.82. In the year 2008, what is the difference between the Expenditure(as % of GDP) of Andorra and Expenditure(as % of GDP) of Switzerland?
Your answer should be very brief. -4.19. In the year 2008, what is the difference between the Expenditure(as % of GDP) of France and Expenditure(as % of GDP) of Switzerland?
Keep it short and to the point. 0.62. In the year 2009, what is the difference between the Expenditure(as % of GDP) in High income: nonOECD and Expenditure(as % of GDP) in Andorra?
Provide a short and direct response. 0.07. In the year 2009, what is the difference between the Expenditure(as % of GDP) of High income: nonOECD and Expenditure(as % of GDP) of France?
Offer a terse response. -5.45. In the year 2009, what is the difference between the Expenditure(as % of GDP) of High income: nonOECD and Expenditure(as % of GDP) of Switzerland?
Give a very brief answer. -4.86. In the year 2009, what is the difference between the Expenditure(as % of GDP) in Andorra and Expenditure(as % of GDP) in France?
Offer a terse response. -5.52. In the year 2009, what is the difference between the Expenditure(as % of GDP) in Andorra and Expenditure(as % of GDP) in Switzerland?
Your response must be concise. -4.92. In the year 2009, what is the difference between the Expenditure(as % of GDP) of France and Expenditure(as % of GDP) of Switzerland?
Ensure brevity in your answer.  0.6. What is the ratio of the Expenditure(as % of GDP) in High income: nonOECD in 2003 to that in 2004?
Provide a succinct answer. 1.08. What is the ratio of the Expenditure(as % of GDP) of Andorra in 2003 to that in 2004?
Your answer should be compact. 1.01. What is the ratio of the Expenditure(as % of GDP) in France in 2003 to that in 2004?
Your answer should be compact. 0.99. What is the ratio of the Expenditure(as % of GDP) of High income: nonOECD in 2003 to that in 2005?
Make the answer very short. 1.09. What is the ratio of the Expenditure(as % of GDP) of Andorra in 2003 to that in 2005?
Make the answer very short. 1. What is the ratio of the Expenditure(as % of GDP) of France in 2003 to that in 2005?
Keep it short and to the point. 0.98. What is the ratio of the Expenditure(as % of GDP) in High income: nonOECD in 2003 to that in 2006?
Give a very brief answer. 1.08. What is the ratio of the Expenditure(as % of GDP) in Andorra in 2003 to that in 2006?
Keep it short and to the point. 0.96. What is the ratio of the Expenditure(as % of GDP) in France in 2003 to that in 2006?
Your response must be concise. 0.99. What is the ratio of the Expenditure(as % of GDP) in Switzerland in 2003 to that in 2006?
Offer a terse response. 1.05. What is the ratio of the Expenditure(as % of GDP) in High income: nonOECD in 2003 to that in 2007?
Offer a very short reply. 1.06. What is the ratio of the Expenditure(as % of GDP) in Andorra in 2003 to that in 2007?
Give a very brief answer. 0.95. What is the ratio of the Expenditure(as % of GDP) in Switzerland in 2003 to that in 2007?
Provide a succinct answer. 1.07. What is the ratio of the Expenditure(as % of GDP) of High income: nonOECD in 2003 to that in 2008?
Offer a terse response. 1. What is the ratio of the Expenditure(as % of GDP) in Andorra in 2003 to that in 2008?
Offer a very short reply. 0.95. What is the ratio of the Expenditure(as % of GDP) in France in 2003 to that in 2008?
Keep it short and to the point. 0.99. What is the ratio of the Expenditure(as % of GDP) of Switzerland in 2003 to that in 2008?
Offer a very short reply. 1.06. What is the ratio of the Expenditure(as % of GDP) of High income: nonOECD in 2003 to that in 2009?
Your answer should be compact. 0.83. What is the ratio of the Expenditure(as % of GDP) in Andorra in 2003 to that in 2009?
Give a very brief answer. 0.95. What is the ratio of the Expenditure(as % of GDP) of France in 2003 to that in 2009?
Give a very brief answer. 0.93. What is the ratio of the Expenditure(as % of GDP) of High income: nonOECD in 2004 to that in 2005?
Provide a short and direct response. 1.01. What is the ratio of the Expenditure(as % of GDP) in France in 2004 to that in 2005?
Your answer should be very brief. 1. What is the ratio of the Expenditure(as % of GDP) in Switzerland in 2004 to that in 2005?
Give a very brief answer. 1.01. What is the ratio of the Expenditure(as % of GDP) in Andorra in 2004 to that in 2006?
Offer a terse response. 0.95. What is the ratio of the Expenditure(as % of GDP) in Switzerland in 2004 to that in 2006?
Your answer should be compact. 1.06. What is the ratio of the Expenditure(as % of GDP) in High income: nonOECD in 2004 to that in 2007?
Make the answer very short. 0.98. What is the ratio of the Expenditure(as % of GDP) in Andorra in 2004 to that in 2007?
Your answer should be compact. 0.94. What is the ratio of the Expenditure(as % of GDP) of France in 2004 to that in 2007?
Keep it short and to the point. 1.01. What is the ratio of the Expenditure(as % of GDP) of Switzerland in 2004 to that in 2007?
Provide a short and direct response. 1.07. What is the ratio of the Expenditure(as % of GDP) of High income: nonOECD in 2004 to that in 2008?
Offer a terse response. 0.93. What is the ratio of the Expenditure(as % of GDP) of Andorra in 2004 to that in 2008?
Provide a short and direct response. 0.94. What is the ratio of the Expenditure(as % of GDP) of Switzerland in 2004 to that in 2008?
Your answer should be very brief. 1.07. What is the ratio of the Expenditure(as % of GDP) of High income: nonOECD in 2004 to that in 2009?
Provide a succinct answer. 0.77. What is the ratio of the Expenditure(as % of GDP) of Andorra in 2004 to that in 2009?
Provide a succinct answer. 0.94. What is the ratio of the Expenditure(as % of GDP) of France in 2004 to that in 2009?
Your answer should be very brief. 0.94. What is the ratio of the Expenditure(as % of GDP) of Switzerland in 2004 to that in 2009?
Ensure brevity in your answer.  1. What is the ratio of the Expenditure(as % of GDP) in High income: nonOECD in 2005 to that in 2006?
Your response must be concise. 0.99. What is the ratio of the Expenditure(as % of GDP) in Andorra in 2005 to that in 2006?
Ensure brevity in your answer.  0.96. What is the ratio of the Expenditure(as % of GDP) of France in 2005 to that in 2006?
Give a very brief answer. 1.01. What is the ratio of the Expenditure(as % of GDP) in Switzerland in 2005 to that in 2006?
Your response must be concise. 1.05. What is the ratio of the Expenditure(as % of GDP) of High income: nonOECD in 2005 to that in 2007?
Keep it short and to the point. 0.97. What is the ratio of the Expenditure(as % of GDP) in Andorra in 2005 to that in 2007?
Give a very brief answer. 0.94. What is the ratio of the Expenditure(as % of GDP) of France in 2005 to that in 2007?
Keep it short and to the point. 1.01. What is the ratio of the Expenditure(as % of GDP) of Switzerland in 2005 to that in 2007?
Provide a short and direct response. 1.06. What is the ratio of the Expenditure(as % of GDP) of High income: nonOECD in 2005 to that in 2008?
Your answer should be compact. 0.92. What is the ratio of the Expenditure(as % of GDP) in Andorra in 2005 to that in 2008?
Offer a very short reply. 0.94. What is the ratio of the Expenditure(as % of GDP) in Switzerland in 2005 to that in 2008?
Offer a terse response. 1.06. What is the ratio of the Expenditure(as % of GDP) of High income: nonOECD in 2005 to that in 2009?
Give a very brief answer. 0.76. What is the ratio of the Expenditure(as % of GDP) of Andorra in 2005 to that in 2009?
Provide a short and direct response. 0.95. What is the ratio of the Expenditure(as % of GDP) of France in 2005 to that in 2009?
Make the answer very short. 0.94. What is the ratio of the Expenditure(as % of GDP) of Switzerland in 2005 to that in 2009?
Make the answer very short. 0.99. What is the ratio of the Expenditure(as % of GDP) of High income: nonOECD in 2006 to that in 2007?
Provide a succinct answer. 0.98. What is the ratio of the Expenditure(as % of GDP) of Andorra in 2006 to that in 2007?
Your response must be concise. 0.98. What is the ratio of the Expenditure(as % of GDP) in Switzerland in 2006 to that in 2007?
Give a very brief answer. 1.02. What is the ratio of the Expenditure(as % of GDP) in High income: nonOECD in 2006 to that in 2008?
Give a very brief answer. 0.93. What is the ratio of the Expenditure(as % of GDP) of Andorra in 2006 to that in 2008?
Your response must be concise. 0.98. What is the ratio of the Expenditure(as % of GDP) in France in 2006 to that in 2008?
Offer a terse response. 0.99. What is the ratio of the Expenditure(as % of GDP) of Switzerland in 2006 to that in 2008?
Your response must be concise. 1.01. What is the ratio of the Expenditure(as % of GDP) in High income: nonOECD in 2006 to that in 2009?
Your answer should be very brief. 0.77. What is the ratio of the Expenditure(as % of GDP) in France in 2006 to that in 2009?
Offer a very short reply. 0.94. What is the ratio of the Expenditure(as % of GDP) in Switzerland in 2006 to that in 2009?
Keep it short and to the point. 0.94. What is the ratio of the Expenditure(as % of GDP) of High income: nonOECD in 2007 to that in 2008?
Give a very brief answer. 0.95. What is the ratio of the Expenditure(as % of GDP) in Andorra in 2007 to that in 2008?
Ensure brevity in your answer.  1. What is the ratio of the Expenditure(as % of GDP) in France in 2007 to that in 2008?
Ensure brevity in your answer.  0.99. What is the ratio of the Expenditure(as % of GDP) of Switzerland in 2007 to that in 2008?
Your answer should be very brief. 0.99. What is the ratio of the Expenditure(as % of GDP) in High income: nonOECD in 2007 to that in 2009?
Provide a succinct answer. 0.78. What is the ratio of the Expenditure(as % of GDP) in France in 2007 to that in 2009?
Provide a succinct answer. 0.93. What is the ratio of the Expenditure(as % of GDP) in Switzerland in 2007 to that in 2009?
Provide a short and direct response. 0.93. What is the ratio of the Expenditure(as % of GDP) in High income: nonOECD in 2008 to that in 2009?
Offer a terse response. 0.82. What is the ratio of the Expenditure(as % of GDP) in Andorra in 2008 to that in 2009?
Your answer should be very brief. 1. What is the ratio of the Expenditure(as % of GDP) of France in 2008 to that in 2009?
Your answer should be compact. 0.94. What is the ratio of the Expenditure(as % of GDP) of Switzerland in 2008 to that in 2009?
Your response must be concise. 0.94. What is the difference between the highest and the second highest Expenditure(as % of GDP) of High income: nonOECD?
Offer a very short reply. 1.05. What is the difference between the highest and the second highest Expenditure(as % of GDP) in Andorra?
Ensure brevity in your answer.  0.01. What is the difference between the highest and the second highest Expenditure(as % of GDP) of France?
Your answer should be very brief. 0.67. What is the difference between the highest and the second highest Expenditure(as % of GDP) in Switzerland?
Your answer should be very brief. 0.04. What is the difference between the highest and the lowest Expenditure(as % of GDP) of High income: nonOECD?
Your response must be concise. 1.47. What is the difference between the highest and the lowest Expenditure(as % of GDP) of Andorra?
Give a very brief answer. 0.39. What is the difference between the highest and the lowest Expenditure(as % of GDP) in France?
Offer a terse response. 0.85. What is the difference between the highest and the lowest Expenditure(as % of GDP) in Switzerland?
Keep it short and to the point. 0.79. 